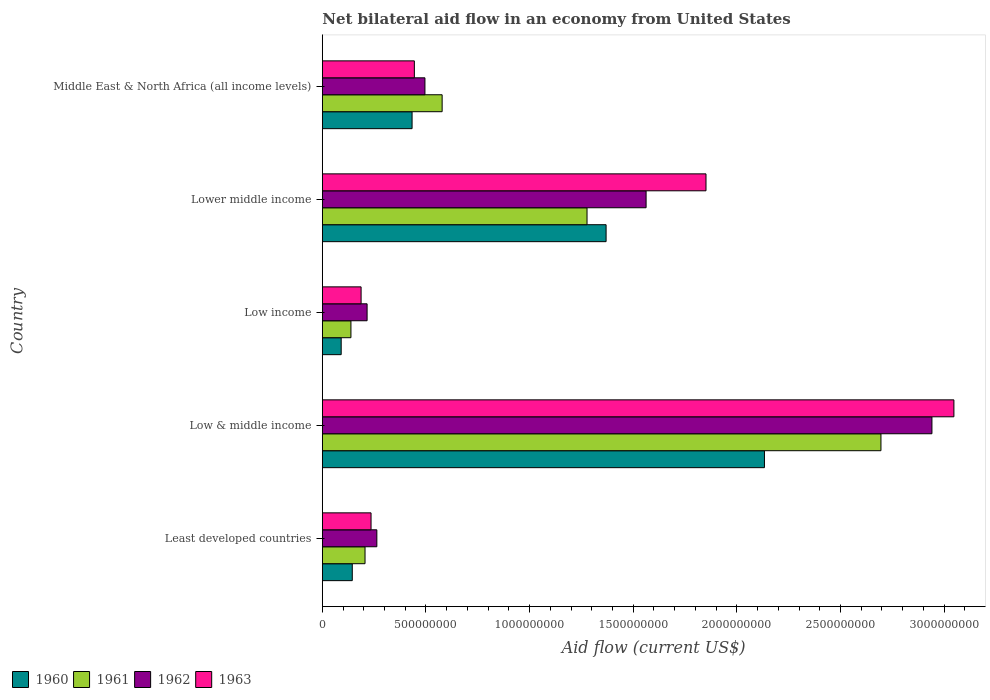Are the number of bars on each tick of the Y-axis equal?
Provide a short and direct response. Yes. What is the net bilateral aid flow in 1962 in Low & middle income?
Give a very brief answer. 2.94e+09. Across all countries, what is the maximum net bilateral aid flow in 1960?
Offer a terse response. 2.13e+09. Across all countries, what is the minimum net bilateral aid flow in 1962?
Your answer should be compact. 2.16e+08. In which country was the net bilateral aid flow in 1961 minimum?
Offer a terse response. Low income. What is the total net bilateral aid flow in 1961 in the graph?
Provide a succinct answer. 4.89e+09. What is the difference between the net bilateral aid flow in 1960 in Low & middle income and that in Middle East & North Africa (all income levels)?
Offer a terse response. 1.70e+09. What is the difference between the net bilateral aid flow in 1960 in Middle East & North Africa (all income levels) and the net bilateral aid flow in 1962 in Low & middle income?
Provide a succinct answer. -2.51e+09. What is the average net bilateral aid flow in 1961 per country?
Your response must be concise. 9.79e+08. What is the difference between the net bilateral aid flow in 1962 and net bilateral aid flow in 1960 in Low & middle income?
Ensure brevity in your answer.  8.08e+08. What is the ratio of the net bilateral aid flow in 1961 in Low & middle income to that in Middle East & North Africa (all income levels)?
Provide a short and direct response. 4.66. Is the net bilateral aid flow in 1961 in Least developed countries less than that in Middle East & North Africa (all income levels)?
Make the answer very short. Yes. What is the difference between the highest and the second highest net bilateral aid flow in 1963?
Offer a terse response. 1.20e+09. What is the difference between the highest and the lowest net bilateral aid flow in 1961?
Keep it short and to the point. 2.56e+09. In how many countries, is the net bilateral aid flow in 1963 greater than the average net bilateral aid flow in 1963 taken over all countries?
Ensure brevity in your answer.  2. Is the sum of the net bilateral aid flow in 1963 in Low & middle income and Low income greater than the maximum net bilateral aid flow in 1960 across all countries?
Provide a succinct answer. Yes. Is it the case that in every country, the sum of the net bilateral aid flow in 1961 and net bilateral aid flow in 1960 is greater than the sum of net bilateral aid flow in 1963 and net bilateral aid flow in 1962?
Make the answer very short. No. What does the 1st bar from the top in Least developed countries represents?
Keep it short and to the point. 1963. What does the 1st bar from the bottom in Low & middle income represents?
Provide a short and direct response. 1960. Are all the bars in the graph horizontal?
Make the answer very short. Yes. How many countries are there in the graph?
Provide a succinct answer. 5. Are the values on the major ticks of X-axis written in scientific E-notation?
Your answer should be very brief. No. Does the graph contain any zero values?
Your response must be concise. No. How many legend labels are there?
Your answer should be very brief. 4. What is the title of the graph?
Keep it short and to the point. Net bilateral aid flow in an economy from United States. Does "2010" appear as one of the legend labels in the graph?
Offer a terse response. No. What is the label or title of the X-axis?
Your answer should be compact. Aid flow (current US$). What is the label or title of the Y-axis?
Keep it short and to the point. Country. What is the Aid flow (current US$) in 1960 in Least developed countries?
Provide a succinct answer. 1.45e+08. What is the Aid flow (current US$) of 1961 in Least developed countries?
Give a very brief answer. 2.06e+08. What is the Aid flow (current US$) in 1962 in Least developed countries?
Your answer should be very brief. 2.63e+08. What is the Aid flow (current US$) in 1963 in Least developed countries?
Your answer should be compact. 2.35e+08. What is the Aid flow (current US$) in 1960 in Low & middle income?
Make the answer very short. 2.13e+09. What is the Aid flow (current US$) of 1961 in Low & middle income?
Make the answer very short. 2.70e+09. What is the Aid flow (current US$) of 1962 in Low & middle income?
Provide a short and direct response. 2.94e+09. What is the Aid flow (current US$) in 1963 in Low & middle income?
Give a very brief answer. 3.05e+09. What is the Aid flow (current US$) in 1960 in Low income?
Provide a short and direct response. 9.10e+07. What is the Aid flow (current US$) in 1961 in Low income?
Give a very brief answer. 1.38e+08. What is the Aid flow (current US$) in 1962 in Low income?
Ensure brevity in your answer.  2.16e+08. What is the Aid flow (current US$) in 1963 in Low income?
Your answer should be very brief. 1.87e+08. What is the Aid flow (current US$) in 1960 in Lower middle income?
Ensure brevity in your answer.  1.37e+09. What is the Aid flow (current US$) in 1961 in Lower middle income?
Your response must be concise. 1.28e+09. What is the Aid flow (current US$) of 1962 in Lower middle income?
Provide a succinct answer. 1.56e+09. What is the Aid flow (current US$) of 1963 in Lower middle income?
Offer a very short reply. 1.85e+09. What is the Aid flow (current US$) of 1960 in Middle East & North Africa (all income levels)?
Offer a very short reply. 4.33e+08. What is the Aid flow (current US$) in 1961 in Middle East & North Africa (all income levels)?
Make the answer very short. 5.78e+08. What is the Aid flow (current US$) in 1962 in Middle East & North Africa (all income levels)?
Give a very brief answer. 4.95e+08. What is the Aid flow (current US$) in 1963 in Middle East & North Africa (all income levels)?
Your answer should be very brief. 4.44e+08. Across all countries, what is the maximum Aid flow (current US$) in 1960?
Provide a succinct answer. 2.13e+09. Across all countries, what is the maximum Aid flow (current US$) of 1961?
Give a very brief answer. 2.70e+09. Across all countries, what is the maximum Aid flow (current US$) in 1962?
Provide a succinct answer. 2.94e+09. Across all countries, what is the maximum Aid flow (current US$) of 1963?
Provide a succinct answer. 3.05e+09. Across all countries, what is the minimum Aid flow (current US$) of 1960?
Offer a very short reply. 9.10e+07. Across all countries, what is the minimum Aid flow (current US$) of 1961?
Offer a terse response. 1.38e+08. Across all countries, what is the minimum Aid flow (current US$) of 1962?
Keep it short and to the point. 2.16e+08. Across all countries, what is the minimum Aid flow (current US$) of 1963?
Provide a succinct answer. 1.87e+08. What is the total Aid flow (current US$) of 1960 in the graph?
Make the answer very short. 4.17e+09. What is the total Aid flow (current US$) of 1961 in the graph?
Offer a terse response. 4.89e+09. What is the total Aid flow (current US$) in 1962 in the graph?
Provide a short and direct response. 5.48e+09. What is the total Aid flow (current US$) in 1963 in the graph?
Offer a terse response. 5.76e+09. What is the difference between the Aid flow (current US$) of 1960 in Least developed countries and that in Low & middle income?
Keep it short and to the point. -1.99e+09. What is the difference between the Aid flow (current US$) in 1961 in Least developed countries and that in Low & middle income?
Make the answer very short. -2.49e+09. What is the difference between the Aid flow (current US$) of 1962 in Least developed countries and that in Low & middle income?
Provide a short and direct response. -2.68e+09. What is the difference between the Aid flow (current US$) of 1963 in Least developed countries and that in Low & middle income?
Offer a terse response. -2.81e+09. What is the difference between the Aid flow (current US$) in 1960 in Least developed countries and that in Low income?
Provide a succinct answer. 5.35e+07. What is the difference between the Aid flow (current US$) in 1961 in Least developed countries and that in Low income?
Your answer should be very brief. 6.80e+07. What is the difference between the Aid flow (current US$) in 1962 in Least developed countries and that in Low income?
Offer a very short reply. 4.70e+07. What is the difference between the Aid flow (current US$) of 1963 in Least developed countries and that in Low income?
Offer a terse response. 4.80e+07. What is the difference between the Aid flow (current US$) of 1960 in Least developed countries and that in Lower middle income?
Make the answer very short. -1.22e+09. What is the difference between the Aid flow (current US$) of 1961 in Least developed countries and that in Lower middle income?
Offer a very short reply. -1.07e+09. What is the difference between the Aid flow (current US$) of 1962 in Least developed countries and that in Lower middle income?
Offer a terse response. -1.30e+09. What is the difference between the Aid flow (current US$) in 1963 in Least developed countries and that in Lower middle income?
Your answer should be very brief. -1.62e+09. What is the difference between the Aid flow (current US$) of 1960 in Least developed countries and that in Middle East & North Africa (all income levels)?
Make the answer very short. -2.88e+08. What is the difference between the Aid flow (current US$) in 1961 in Least developed countries and that in Middle East & North Africa (all income levels)?
Make the answer very short. -3.72e+08. What is the difference between the Aid flow (current US$) of 1962 in Least developed countries and that in Middle East & North Africa (all income levels)?
Keep it short and to the point. -2.32e+08. What is the difference between the Aid flow (current US$) in 1963 in Least developed countries and that in Middle East & North Africa (all income levels)?
Your answer should be compact. -2.09e+08. What is the difference between the Aid flow (current US$) of 1960 in Low & middle income and that in Low income?
Your response must be concise. 2.04e+09. What is the difference between the Aid flow (current US$) in 1961 in Low & middle income and that in Low income?
Ensure brevity in your answer.  2.56e+09. What is the difference between the Aid flow (current US$) in 1962 in Low & middle income and that in Low income?
Your answer should be compact. 2.72e+09. What is the difference between the Aid flow (current US$) of 1963 in Low & middle income and that in Low income?
Offer a very short reply. 2.86e+09. What is the difference between the Aid flow (current US$) in 1960 in Low & middle income and that in Lower middle income?
Your response must be concise. 7.64e+08. What is the difference between the Aid flow (current US$) of 1961 in Low & middle income and that in Lower middle income?
Your answer should be compact. 1.42e+09. What is the difference between the Aid flow (current US$) in 1962 in Low & middle income and that in Lower middle income?
Provide a short and direct response. 1.38e+09. What is the difference between the Aid flow (current US$) of 1963 in Low & middle income and that in Lower middle income?
Provide a succinct answer. 1.20e+09. What is the difference between the Aid flow (current US$) of 1960 in Low & middle income and that in Middle East & North Africa (all income levels)?
Give a very brief answer. 1.70e+09. What is the difference between the Aid flow (current US$) in 1961 in Low & middle income and that in Middle East & North Africa (all income levels)?
Make the answer very short. 2.12e+09. What is the difference between the Aid flow (current US$) in 1962 in Low & middle income and that in Middle East & North Africa (all income levels)?
Give a very brief answer. 2.45e+09. What is the difference between the Aid flow (current US$) of 1963 in Low & middle income and that in Middle East & North Africa (all income levels)?
Offer a terse response. 2.60e+09. What is the difference between the Aid flow (current US$) in 1960 in Low income and that in Lower middle income?
Provide a succinct answer. -1.28e+09. What is the difference between the Aid flow (current US$) of 1961 in Low income and that in Lower middle income?
Your response must be concise. -1.14e+09. What is the difference between the Aid flow (current US$) of 1962 in Low income and that in Lower middle income?
Offer a very short reply. -1.35e+09. What is the difference between the Aid flow (current US$) of 1963 in Low income and that in Lower middle income?
Your answer should be very brief. -1.66e+09. What is the difference between the Aid flow (current US$) in 1960 in Low income and that in Middle East & North Africa (all income levels)?
Provide a succinct answer. -3.42e+08. What is the difference between the Aid flow (current US$) in 1961 in Low income and that in Middle East & North Africa (all income levels)?
Provide a succinct answer. -4.40e+08. What is the difference between the Aid flow (current US$) in 1962 in Low income and that in Middle East & North Africa (all income levels)?
Your answer should be very brief. -2.79e+08. What is the difference between the Aid flow (current US$) in 1963 in Low income and that in Middle East & North Africa (all income levels)?
Ensure brevity in your answer.  -2.57e+08. What is the difference between the Aid flow (current US$) in 1960 in Lower middle income and that in Middle East & North Africa (all income levels)?
Provide a short and direct response. 9.36e+08. What is the difference between the Aid flow (current US$) in 1961 in Lower middle income and that in Middle East & North Africa (all income levels)?
Keep it short and to the point. 6.99e+08. What is the difference between the Aid flow (current US$) of 1962 in Lower middle income and that in Middle East & North Africa (all income levels)?
Your response must be concise. 1.07e+09. What is the difference between the Aid flow (current US$) in 1963 in Lower middle income and that in Middle East & North Africa (all income levels)?
Offer a very short reply. 1.41e+09. What is the difference between the Aid flow (current US$) in 1960 in Least developed countries and the Aid flow (current US$) in 1961 in Low & middle income?
Offer a very short reply. -2.55e+09. What is the difference between the Aid flow (current US$) of 1960 in Least developed countries and the Aid flow (current US$) of 1962 in Low & middle income?
Your response must be concise. -2.80e+09. What is the difference between the Aid flow (current US$) of 1960 in Least developed countries and the Aid flow (current US$) of 1963 in Low & middle income?
Offer a terse response. -2.90e+09. What is the difference between the Aid flow (current US$) of 1961 in Least developed countries and the Aid flow (current US$) of 1962 in Low & middle income?
Keep it short and to the point. -2.74e+09. What is the difference between the Aid flow (current US$) in 1961 in Least developed countries and the Aid flow (current US$) in 1963 in Low & middle income?
Provide a succinct answer. -2.84e+09. What is the difference between the Aid flow (current US$) of 1962 in Least developed countries and the Aid flow (current US$) of 1963 in Low & middle income?
Provide a succinct answer. -2.78e+09. What is the difference between the Aid flow (current US$) of 1960 in Least developed countries and the Aid flow (current US$) of 1961 in Low income?
Make the answer very short. 6.52e+06. What is the difference between the Aid flow (current US$) of 1960 in Least developed countries and the Aid flow (current US$) of 1962 in Low income?
Make the answer very short. -7.15e+07. What is the difference between the Aid flow (current US$) in 1960 in Least developed countries and the Aid flow (current US$) in 1963 in Low income?
Offer a very short reply. -4.25e+07. What is the difference between the Aid flow (current US$) of 1961 in Least developed countries and the Aid flow (current US$) of 1962 in Low income?
Offer a terse response. -1.00e+07. What is the difference between the Aid flow (current US$) of 1961 in Least developed countries and the Aid flow (current US$) of 1963 in Low income?
Give a very brief answer. 1.90e+07. What is the difference between the Aid flow (current US$) in 1962 in Least developed countries and the Aid flow (current US$) in 1963 in Low income?
Keep it short and to the point. 7.60e+07. What is the difference between the Aid flow (current US$) in 1960 in Least developed countries and the Aid flow (current US$) in 1961 in Lower middle income?
Provide a short and direct response. -1.13e+09. What is the difference between the Aid flow (current US$) in 1960 in Least developed countries and the Aid flow (current US$) in 1962 in Lower middle income?
Offer a terse response. -1.42e+09. What is the difference between the Aid flow (current US$) in 1960 in Least developed countries and the Aid flow (current US$) in 1963 in Lower middle income?
Give a very brief answer. -1.71e+09. What is the difference between the Aid flow (current US$) in 1961 in Least developed countries and the Aid flow (current US$) in 1962 in Lower middle income?
Your answer should be very brief. -1.36e+09. What is the difference between the Aid flow (current US$) in 1961 in Least developed countries and the Aid flow (current US$) in 1963 in Lower middle income?
Your answer should be compact. -1.64e+09. What is the difference between the Aid flow (current US$) of 1962 in Least developed countries and the Aid flow (current US$) of 1963 in Lower middle income?
Offer a terse response. -1.59e+09. What is the difference between the Aid flow (current US$) of 1960 in Least developed countries and the Aid flow (current US$) of 1961 in Middle East & North Africa (all income levels)?
Ensure brevity in your answer.  -4.33e+08. What is the difference between the Aid flow (current US$) of 1960 in Least developed countries and the Aid flow (current US$) of 1962 in Middle East & North Africa (all income levels)?
Give a very brief answer. -3.50e+08. What is the difference between the Aid flow (current US$) of 1960 in Least developed countries and the Aid flow (current US$) of 1963 in Middle East & North Africa (all income levels)?
Offer a terse response. -2.99e+08. What is the difference between the Aid flow (current US$) in 1961 in Least developed countries and the Aid flow (current US$) in 1962 in Middle East & North Africa (all income levels)?
Your response must be concise. -2.89e+08. What is the difference between the Aid flow (current US$) in 1961 in Least developed countries and the Aid flow (current US$) in 1963 in Middle East & North Africa (all income levels)?
Offer a very short reply. -2.38e+08. What is the difference between the Aid flow (current US$) of 1962 in Least developed countries and the Aid flow (current US$) of 1963 in Middle East & North Africa (all income levels)?
Your answer should be very brief. -1.81e+08. What is the difference between the Aid flow (current US$) in 1960 in Low & middle income and the Aid flow (current US$) in 1961 in Low income?
Provide a short and direct response. 2.00e+09. What is the difference between the Aid flow (current US$) in 1960 in Low & middle income and the Aid flow (current US$) in 1962 in Low income?
Provide a short and direct response. 1.92e+09. What is the difference between the Aid flow (current US$) of 1960 in Low & middle income and the Aid flow (current US$) of 1963 in Low income?
Offer a very short reply. 1.95e+09. What is the difference between the Aid flow (current US$) of 1961 in Low & middle income and the Aid flow (current US$) of 1962 in Low income?
Offer a very short reply. 2.48e+09. What is the difference between the Aid flow (current US$) of 1961 in Low & middle income and the Aid flow (current US$) of 1963 in Low income?
Provide a succinct answer. 2.51e+09. What is the difference between the Aid flow (current US$) of 1962 in Low & middle income and the Aid flow (current US$) of 1963 in Low income?
Your response must be concise. 2.75e+09. What is the difference between the Aid flow (current US$) of 1960 in Low & middle income and the Aid flow (current US$) of 1961 in Lower middle income?
Your answer should be very brief. 8.56e+08. What is the difference between the Aid flow (current US$) in 1960 in Low & middle income and the Aid flow (current US$) in 1962 in Lower middle income?
Give a very brief answer. 5.71e+08. What is the difference between the Aid flow (current US$) of 1960 in Low & middle income and the Aid flow (current US$) of 1963 in Lower middle income?
Your answer should be compact. 2.82e+08. What is the difference between the Aid flow (current US$) in 1961 in Low & middle income and the Aid flow (current US$) in 1962 in Lower middle income?
Make the answer very short. 1.13e+09. What is the difference between the Aid flow (current US$) in 1961 in Low & middle income and the Aid flow (current US$) in 1963 in Lower middle income?
Make the answer very short. 8.44e+08. What is the difference between the Aid flow (current US$) of 1962 in Low & middle income and the Aid flow (current US$) of 1963 in Lower middle income?
Keep it short and to the point. 1.09e+09. What is the difference between the Aid flow (current US$) in 1960 in Low & middle income and the Aid flow (current US$) in 1961 in Middle East & North Africa (all income levels)?
Provide a succinct answer. 1.56e+09. What is the difference between the Aid flow (current US$) in 1960 in Low & middle income and the Aid flow (current US$) in 1962 in Middle East & North Africa (all income levels)?
Your answer should be very brief. 1.64e+09. What is the difference between the Aid flow (current US$) in 1960 in Low & middle income and the Aid flow (current US$) in 1963 in Middle East & North Africa (all income levels)?
Offer a terse response. 1.69e+09. What is the difference between the Aid flow (current US$) in 1961 in Low & middle income and the Aid flow (current US$) in 1962 in Middle East & North Africa (all income levels)?
Offer a very short reply. 2.20e+09. What is the difference between the Aid flow (current US$) in 1961 in Low & middle income and the Aid flow (current US$) in 1963 in Middle East & North Africa (all income levels)?
Ensure brevity in your answer.  2.25e+09. What is the difference between the Aid flow (current US$) in 1962 in Low & middle income and the Aid flow (current US$) in 1963 in Middle East & North Africa (all income levels)?
Provide a succinct answer. 2.50e+09. What is the difference between the Aid flow (current US$) in 1960 in Low income and the Aid flow (current US$) in 1961 in Lower middle income?
Provide a succinct answer. -1.19e+09. What is the difference between the Aid flow (current US$) of 1960 in Low income and the Aid flow (current US$) of 1962 in Lower middle income?
Your answer should be very brief. -1.47e+09. What is the difference between the Aid flow (current US$) in 1960 in Low income and the Aid flow (current US$) in 1963 in Lower middle income?
Offer a very short reply. -1.76e+09. What is the difference between the Aid flow (current US$) of 1961 in Low income and the Aid flow (current US$) of 1962 in Lower middle income?
Ensure brevity in your answer.  -1.42e+09. What is the difference between the Aid flow (current US$) of 1961 in Low income and the Aid flow (current US$) of 1963 in Lower middle income?
Offer a very short reply. -1.71e+09. What is the difference between the Aid flow (current US$) in 1962 in Low income and the Aid flow (current US$) in 1963 in Lower middle income?
Your answer should be very brief. -1.64e+09. What is the difference between the Aid flow (current US$) in 1960 in Low income and the Aid flow (current US$) in 1961 in Middle East & North Africa (all income levels)?
Keep it short and to the point. -4.87e+08. What is the difference between the Aid flow (current US$) in 1960 in Low income and the Aid flow (current US$) in 1962 in Middle East & North Africa (all income levels)?
Provide a succinct answer. -4.04e+08. What is the difference between the Aid flow (current US$) in 1960 in Low income and the Aid flow (current US$) in 1963 in Middle East & North Africa (all income levels)?
Offer a very short reply. -3.53e+08. What is the difference between the Aid flow (current US$) of 1961 in Low income and the Aid flow (current US$) of 1962 in Middle East & North Africa (all income levels)?
Provide a short and direct response. -3.57e+08. What is the difference between the Aid flow (current US$) of 1961 in Low income and the Aid flow (current US$) of 1963 in Middle East & North Africa (all income levels)?
Offer a terse response. -3.06e+08. What is the difference between the Aid flow (current US$) of 1962 in Low income and the Aid flow (current US$) of 1963 in Middle East & North Africa (all income levels)?
Keep it short and to the point. -2.28e+08. What is the difference between the Aid flow (current US$) of 1960 in Lower middle income and the Aid flow (current US$) of 1961 in Middle East & North Africa (all income levels)?
Make the answer very short. 7.91e+08. What is the difference between the Aid flow (current US$) of 1960 in Lower middle income and the Aid flow (current US$) of 1962 in Middle East & North Africa (all income levels)?
Your response must be concise. 8.74e+08. What is the difference between the Aid flow (current US$) of 1960 in Lower middle income and the Aid flow (current US$) of 1963 in Middle East & North Africa (all income levels)?
Provide a succinct answer. 9.25e+08. What is the difference between the Aid flow (current US$) of 1961 in Lower middle income and the Aid flow (current US$) of 1962 in Middle East & North Africa (all income levels)?
Your answer should be very brief. 7.82e+08. What is the difference between the Aid flow (current US$) in 1961 in Lower middle income and the Aid flow (current US$) in 1963 in Middle East & North Africa (all income levels)?
Offer a very short reply. 8.33e+08. What is the difference between the Aid flow (current US$) in 1962 in Lower middle income and the Aid flow (current US$) in 1963 in Middle East & North Africa (all income levels)?
Ensure brevity in your answer.  1.12e+09. What is the average Aid flow (current US$) of 1960 per country?
Make the answer very short. 8.34e+08. What is the average Aid flow (current US$) in 1961 per country?
Provide a short and direct response. 9.79e+08. What is the average Aid flow (current US$) of 1962 per country?
Offer a very short reply. 1.10e+09. What is the average Aid flow (current US$) in 1963 per country?
Provide a succinct answer. 1.15e+09. What is the difference between the Aid flow (current US$) of 1960 and Aid flow (current US$) of 1961 in Least developed countries?
Provide a succinct answer. -6.15e+07. What is the difference between the Aid flow (current US$) in 1960 and Aid flow (current US$) in 1962 in Least developed countries?
Your response must be concise. -1.18e+08. What is the difference between the Aid flow (current US$) of 1960 and Aid flow (current US$) of 1963 in Least developed countries?
Make the answer very short. -9.05e+07. What is the difference between the Aid flow (current US$) in 1961 and Aid flow (current US$) in 1962 in Least developed countries?
Your answer should be very brief. -5.70e+07. What is the difference between the Aid flow (current US$) in 1961 and Aid flow (current US$) in 1963 in Least developed countries?
Your response must be concise. -2.90e+07. What is the difference between the Aid flow (current US$) in 1962 and Aid flow (current US$) in 1963 in Least developed countries?
Your response must be concise. 2.80e+07. What is the difference between the Aid flow (current US$) in 1960 and Aid flow (current US$) in 1961 in Low & middle income?
Give a very brief answer. -5.62e+08. What is the difference between the Aid flow (current US$) of 1960 and Aid flow (current US$) of 1962 in Low & middle income?
Your response must be concise. -8.08e+08. What is the difference between the Aid flow (current US$) of 1960 and Aid flow (current US$) of 1963 in Low & middle income?
Offer a very short reply. -9.14e+08. What is the difference between the Aid flow (current US$) of 1961 and Aid flow (current US$) of 1962 in Low & middle income?
Offer a terse response. -2.46e+08. What is the difference between the Aid flow (current US$) of 1961 and Aid flow (current US$) of 1963 in Low & middle income?
Your answer should be very brief. -3.52e+08. What is the difference between the Aid flow (current US$) of 1962 and Aid flow (current US$) of 1963 in Low & middle income?
Make the answer very short. -1.06e+08. What is the difference between the Aid flow (current US$) of 1960 and Aid flow (current US$) of 1961 in Low income?
Your answer should be compact. -4.70e+07. What is the difference between the Aid flow (current US$) in 1960 and Aid flow (current US$) in 1962 in Low income?
Provide a succinct answer. -1.25e+08. What is the difference between the Aid flow (current US$) in 1960 and Aid flow (current US$) in 1963 in Low income?
Ensure brevity in your answer.  -9.60e+07. What is the difference between the Aid flow (current US$) in 1961 and Aid flow (current US$) in 1962 in Low income?
Ensure brevity in your answer.  -7.80e+07. What is the difference between the Aid flow (current US$) in 1961 and Aid flow (current US$) in 1963 in Low income?
Give a very brief answer. -4.90e+07. What is the difference between the Aid flow (current US$) of 1962 and Aid flow (current US$) of 1963 in Low income?
Provide a short and direct response. 2.90e+07. What is the difference between the Aid flow (current US$) of 1960 and Aid flow (current US$) of 1961 in Lower middle income?
Make the answer very short. 9.20e+07. What is the difference between the Aid flow (current US$) in 1960 and Aid flow (current US$) in 1962 in Lower middle income?
Offer a very short reply. -1.93e+08. What is the difference between the Aid flow (current US$) in 1960 and Aid flow (current US$) in 1963 in Lower middle income?
Your answer should be compact. -4.82e+08. What is the difference between the Aid flow (current US$) in 1961 and Aid flow (current US$) in 1962 in Lower middle income?
Make the answer very short. -2.85e+08. What is the difference between the Aid flow (current US$) of 1961 and Aid flow (current US$) of 1963 in Lower middle income?
Make the answer very short. -5.74e+08. What is the difference between the Aid flow (current US$) in 1962 and Aid flow (current US$) in 1963 in Lower middle income?
Provide a succinct answer. -2.89e+08. What is the difference between the Aid flow (current US$) in 1960 and Aid flow (current US$) in 1961 in Middle East & North Africa (all income levels)?
Your answer should be compact. -1.45e+08. What is the difference between the Aid flow (current US$) of 1960 and Aid flow (current US$) of 1962 in Middle East & North Africa (all income levels)?
Offer a very short reply. -6.20e+07. What is the difference between the Aid flow (current US$) of 1960 and Aid flow (current US$) of 1963 in Middle East & North Africa (all income levels)?
Your answer should be compact. -1.10e+07. What is the difference between the Aid flow (current US$) in 1961 and Aid flow (current US$) in 1962 in Middle East & North Africa (all income levels)?
Make the answer very short. 8.30e+07. What is the difference between the Aid flow (current US$) of 1961 and Aid flow (current US$) of 1963 in Middle East & North Africa (all income levels)?
Make the answer very short. 1.34e+08. What is the difference between the Aid flow (current US$) in 1962 and Aid flow (current US$) in 1963 in Middle East & North Africa (all income levels)?
Your answer should be compact. 5.10e+07. What is the ratio of the Aid flow (current US$) in 1960 in Least developed countries to that in Low & middle income?
Give a very brief answer. 0.07. What is the ratio of the Aid flow (current US$) of 1961 in Least developed countries to that in Low & middle income?
Offer a terse response. 0.08. What is the ratio of the Aid flow (current US$) of 1962 in Least developed countries to that in Low & middle income?
Provide a short and direct response. 0.09. What is the ratio of the Aid flow (current US$) of 1963 in Least developed countries to that in Low & middle income?
Offer a very short reply. 0.08. What is the ratio of the Aid flow (current US$) in 1960 in Least developed countries to that in Low income?
Offer a very short reply. 1.59. What is the ratio of the Aid flow (current US$) of 1961 in Least developed countries to that in Low income?
Offer a very short reply. 1.49. What is the ratio of the Aid flow (current US$) in 1962 in Least developed countries to that in Low income?
Make the answer very short. 1.22. What is the ratio of the Aid flow (current US$) of 1963 in Least developed countries to that in Low income?
Provide a succinct answer. 1.26. What is the ratio of the Aid flow (current US$) of 1960 in Least developed countries to that in Lower middle income?
Your answer should be compact. 0.11. What is the ratio of the Aid flow (current US$) of 1961 in Least developed countries to that in Lower middle income?
Ensure brevity in your answer.  0.16. What is the ratio of the Aid flow (current US$) in 1962 in Least developed countries to that in Lower middle income?
Keep it short and to the point. 0.17. What is the ratio of the Aid flow (current US$) of 1963 in Least developed countries to that in Lower middle income?
Your response must be concise. 0.13. What is the ratio of the Aid flow (current US$) of 1960 in Least developed countries to that in Middle East & North Africa (all income levels)?
Give a very brief answer. 0.33. What is the ratio of the Aid flow (current US$) of 1961 in Least developed countries to that in Middle East & North Africa (all income levels)?
Your answer should be very brief. 0.36. What is the ratio of the Aid flow (current US$) in 1962 in Least developed countries to that in Middle East & North Africa (all income levels)?
Give a very brief answer. 0.53. What is the ratio of the Aid flow (current US$) in 1963 in Least developed countries to that in Middle East & North Africa (all income levels)?
Offer a terse response. 0.53. What is the ratio of the Aid flow (current US$) in 1960 in Low & middle income to that in Low income?
Offer a terse response. 23.44. What is the ratio of the Aid flow (current US$) in 1961 in Low & middle income to that in Low income?
Give a very brief answer. 19.53. What is the ratio of the Aid flow (current US$) in 1962 in Low & middle income to that in Low income?
Make the answer very short. 13.62. What is the ratio of the Aid flow (current US$) of 1963 in Low & middle income to that in Low income?
Keep it short and to the point. 16.29. What is the ratio of the Aid flow (current US$) of 1960 in Low & middle income to that in Lower middle income?
Provide a short and direct response. 1.56. What is the ratio of the Aid flow (current US$) in 1961 in Low & middle income to that in Lower middle income?
Make the answer very short. 2.11. What is the ratio of the Aid flow (current US$) of 1962 in Low & middle income to that in Lower middle income?
Make the answer very short. 1.88. What is the ratio of the Aid flow (current US$) in 1963 in Low & middle income to that in Lower middle income?
Your answer should be very brief. 1.65. What is the ratio of the Aid flow (current US$) in 1960 in Low & middle income to that in Middle East & North Africa (all income levels)?
Offer a very short reply. 4.93. What is the ratio of the Aid flow (current US$) in 1961 in Low & middle income to that in Middle East & North Africa (all income levels)?
Make the answer very short. 4.66. What is the ratio of the Aid flow (current US$) in 1962 in Low & middle income to that in Middle East & North Africa (all income levels)?
Your answer should be compact. 5.94. What is the ratio of the Aid flow (current US$) in 1963 in Low & middle income to that in Middle East & North Africa (all income levels)?
Provide a succinct answer. 6.86. What is the ratio of the Aid flow (current US$) in 1960 in Low income to that in Lower middle income?
Ensure brevity in your answer.  0.07. What is the ratio of the Aid flow (current US$) of 1961 in Low income to that in Lower middle income?
Provide a succinct answer. 0.11. What is the ratio of the Aid flow (current US$) of 1962 in Low income to that in Lower middle income?
Provide a short and direct response. 0.14. What is the ratio of the Aid flow (current US$) of 1963 in Low income to that in Lower middle income?
Keep it short and to the point. 0.1. What is the ratio of the Aid flow (current US$) of 1960 in Low income to that in Middle East & North Africa (all income levels)?
Make the answer very short. 0.21. What is the ratio of the Aid flow (current US$) of 1961 in Low income to that in Middle East & North Africa (all income levels)?
Your answer should be very brief. 0.24. What is the ratio of the Aid flow (current US$) in 1962 in Low income to that in Middle East & North Africa (all income levels)?
Provide a succinct answer. 0.44. What is the ratio of the Aid flow (current US$) in 1963 in Low income to that in Middle East & North Africa (all income levels)?
Your response must be concise. 0.42. What is the ratio of the Aid flow (current US$) of 1960 in Lower middle income to that in Middle East & North Africa (all income levels)?
Make the answer very short. 3.16. What is the ratio of the Aid flow (current US$) of 1961 in Lower middle income to that in Middle East & North Africa (all income levels)?
Your answer should be compact. 2.21. What is the ratio of the Aid flow (current US$) in 1962 in Lower middle income to that in Middle East & North Africa (all income levels)?
Offer a very short reply. 3.16. What is the ratio of the Aid flow (current US$) of 1963 in Lower middle income to that in Middle East & North Africa (all income levels)?
Give a very brief answer. 4.17. What is the difference between the highest and the second highest Aid flow (current US$) in 1960?
Offer a very short reply. 7.64e+08. What is the difference between the highest and the second highest Aid flow (current US$) in 1961?
Your answer should be very brief. 1.42e+09. What is the difference between the highest and the second highest Aid flow (current US$) in 1962?
Ensure brevity in your answer.  1.38e+09. What is the difference between the highest and the second highest Aid flow (current US$) in 1963?
Offer a very short reply. 1.20e+09. What is the difference between the highest and the lowest Aid flow (current US$) of 1960?
Your answer should be very brief. 2.04e+09. What is the difference between the highest and the lowest Aid flow (current US$) in 1961?
Offer a very short reply. 2.56e+09. What is the difference between the highest and the lowest Aid flow (current US$) in 1962?
Your answer should be compact. 2.72e+09. What is the difference between the highest and the lowest Aid flow (current US$) of 1963?
Offer a very short reply. 2.86e+09. 